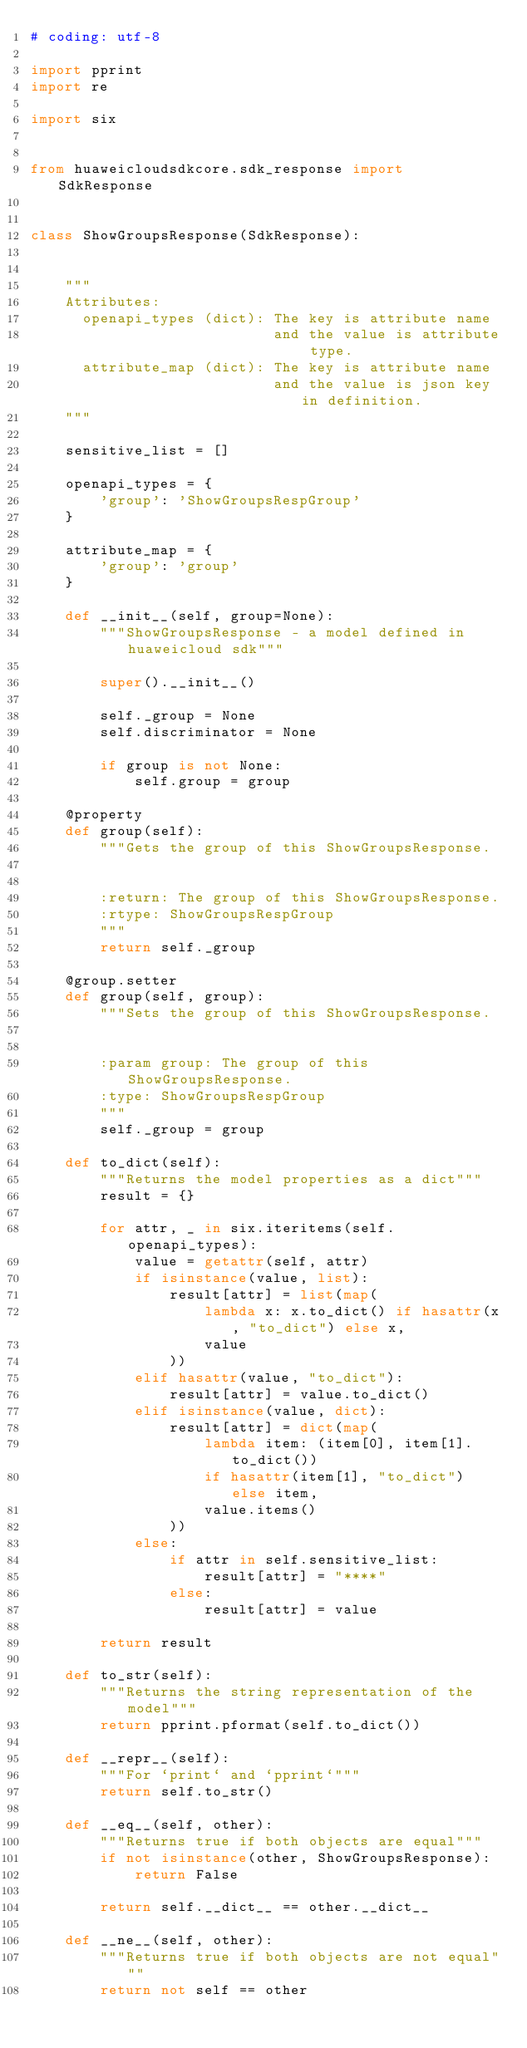<code> <loc_0><loc_0><loc_500><loc_500><_Python_># coding: utf-8

import pprint
import re

import six


from huaweicloudsdkcore.sdk_response import SdkResponse


class ShowGroupsResponse(SdkResponse):


    """
    Attributes:
      openapi_types (dict): The key is attribute name
                            and the value is attribute type.
      attribute_map (dict): The key is attribute name
                            and the value is json key in definition.
    """

    sensitive_list = []

    openapi_types = {
        'group': 'ShowGroupsRespGroup'
    }

    attribute_map = {
        'group': 'group'
    }

    def __init__(self, group=None):
        """ShowGroupsResponse - a model defined in huaweicloud sdk"""
        
        super().__init__()

        self._group = None
        self.discriminator = None

        if group is not None:
            self.group = group

    @property
    def group(self):
        """Gets the group of this ShowGroupsResponse.


        :return: The group of this ShowGroupsResponse.
        :rtype: ShowGroupsRespGroup
        """
        return self._group

    @group.setter
    def group(self, group):
        """Sets the group of this ShowGroupsResponse.


        :param group: The group of this ShowGroupsResponse.
        :type: ShowGroupsRespGroup
        """
        self._group = group

    def to_dict(self):
        """Returns the model properties as a dict"""
        result = {}

        for attr, _ in six.iteritems(self.openapi_types):
            value = getattr(self, attr)
            if isinstance(value, list):
                result[attr] = list(map(
                    lambda x: x.to_dict() if hasattr(x, "to_dict") else x,
                    value
                ))
            elif hasattr(value, "to_dict"):
                result[attr] = value.to_dict()
            elif isinstance(value, dict):
                result[attr] = dict(map(
                    lambda item: (item[0], item[1].to_dict())
                    if hasattr(item[1], "to_dict") else item,
                    value.items()
                ))
            else:
                if attr in self.sensitive_list:
                    result[attr] = "****"
                else:
                    result[attr] = value

        return result

    def to_str(self):
        """Returns the string representation of the model"""
        return pprint.pformat(self.to_dict())

    def __repr__(self):
        """For `print` and `pprint`"""
        return self.to_str()

    def __eq__(self, other):
        """Returns true if both objects are equal"""
        if not isinstance(other, ShowGroupsResponse):
            return False

        return self.__dict__ == other.__dict__

    def __ne__(self, other):
        """Returns true if both objects are not equal"""
        return not self == other
</code> 